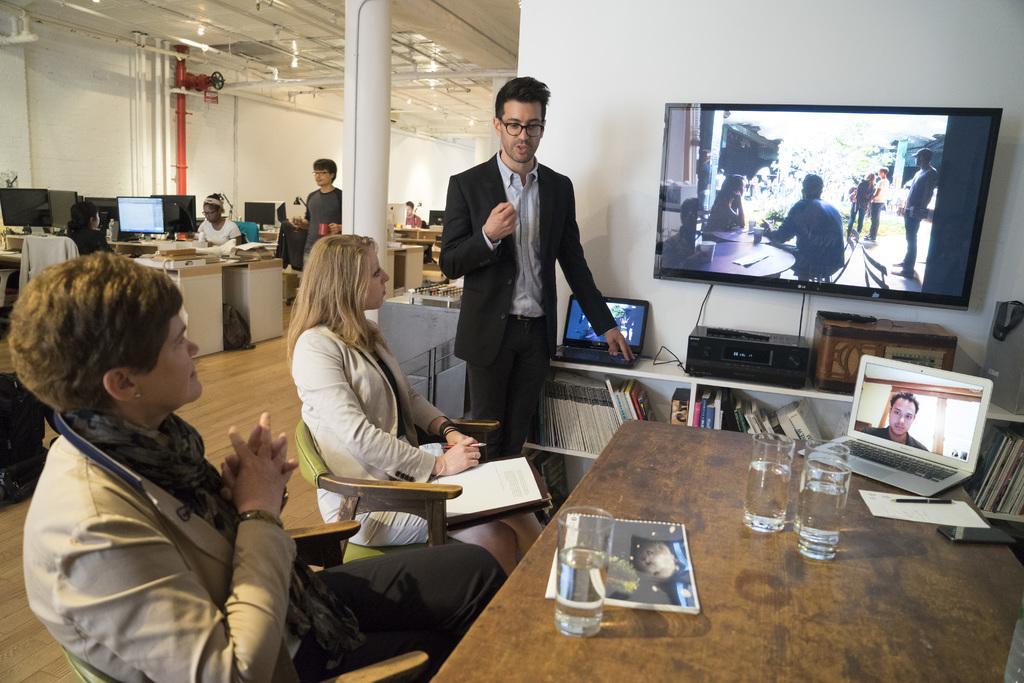Describe this image in one or two sentences. In the picture we can find a man, two women, A man is standing and two women are sitting on the chairs near the table. And a man is standing near the television and explaining something to the two people. In the background we can find some people are sitting on chairs near the desks. On the ceiling we can find some pipes. 